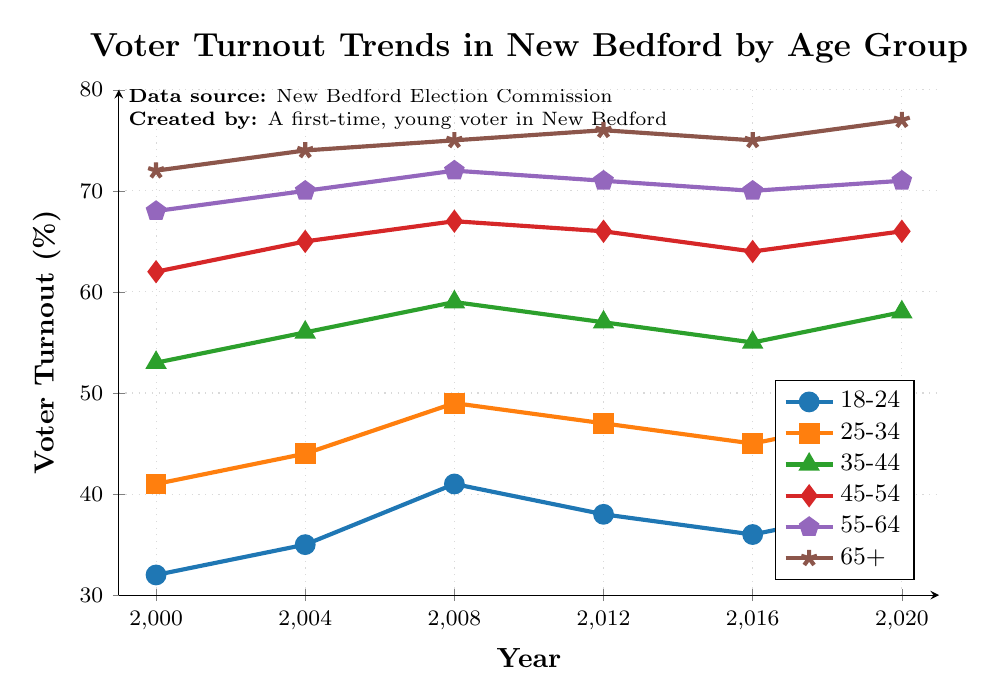What was the voter turnout percentage for the 18-24 age group in 2008? Locate the data point for the 18-24 age group in the year 2008 on the plot. The point is marked with a circle at approximately 41% on the vertical axis.
Answer: 41 Which age group had the highest voter turnout in 2020? Look at the endpoints of the lines at 2020, and observe which line reaches the highest point on the vertical axis. The 65+ age group reaches the highest value.
Answer: 65+ Between which years did the voter turnout for the 35-44 age group increase the most? Compare the change in the 35-44 age group values between each pair of adjacent years: 2000-2004 (3), 2004-2008 (3), 2008-2012 (-2), 2012-2016 (-2), and 2016-2020 (3). The largest increase is between 2004 and 2008.
Answer: 2004-2008 Did the voter turnout for the 45-54 age group ever decrease over the 20-year span? Check the trend of the line representing the 45-54 age group. It shows a decrease from 2008 to 2012 (1), and from 2012 to 2016 (-2), but overall stability in other years.
Answer: Yes What is the average voter turnout for the 55-64 age group over the 20-year period? Add the 55-64 age group data points: 68, 70, 72, 71, 70, 71. Then divide by the number of data points: (68 + 70 + 72 + 71 + 70 + 71)/6 = 70.3333.
Answer: 70.33 Which age group showed the greatest overall increase in voter turnout from 2000 to 2020? Calculate the difference between turnout in 2020 and 2000 for all age groups: 18-24 (39-32=7), 25-34 (48-41=7), 35-44 (58-53=5), 45-54 (66-62=4), 55-64 (71-68=3), 65+ (77-72=5). The 18-24 and 25-34 groups had the greatest increase of 7%.
Answer: 18-24 and 25-34 Was there any year where the turnout for the 18-24 age group was higher than that for the 25-34 age group? Compare the respective data points for each year: 2000 (32 vs 41), 2004 (35 vs 44), 2008 (41 vs 49), 2012 (38 vs 47), 2016 (36 vs 45), 2020 (39 vs 48). None of these years show the 18-24 age group higher than the 25-34 age group.
Answer: No What is the median voter turnout for the 65+ age group over the 20-year period? Organize the 65+ data points in order (72, 74, 75, 76, 75, 77). The median is the average of the middle two values in the ordered list: (75 + 75)/2 = 75.
Answer: 75 In which year did the 18-24 and 55-64 age groups have the same voter turnout percentage? Examine the plot to see if the lines for the 18-24 and 55-64 age groups intersect or are at the same height. There is no year where the two groups intersect or are the same.
Answer: Never How much did the voter turnout for 25-34 age group change from 2000 to 2020? Subtract the voter turnout in 2000 from that in 2020: 48 - 41 = 7.
Answer: 7 